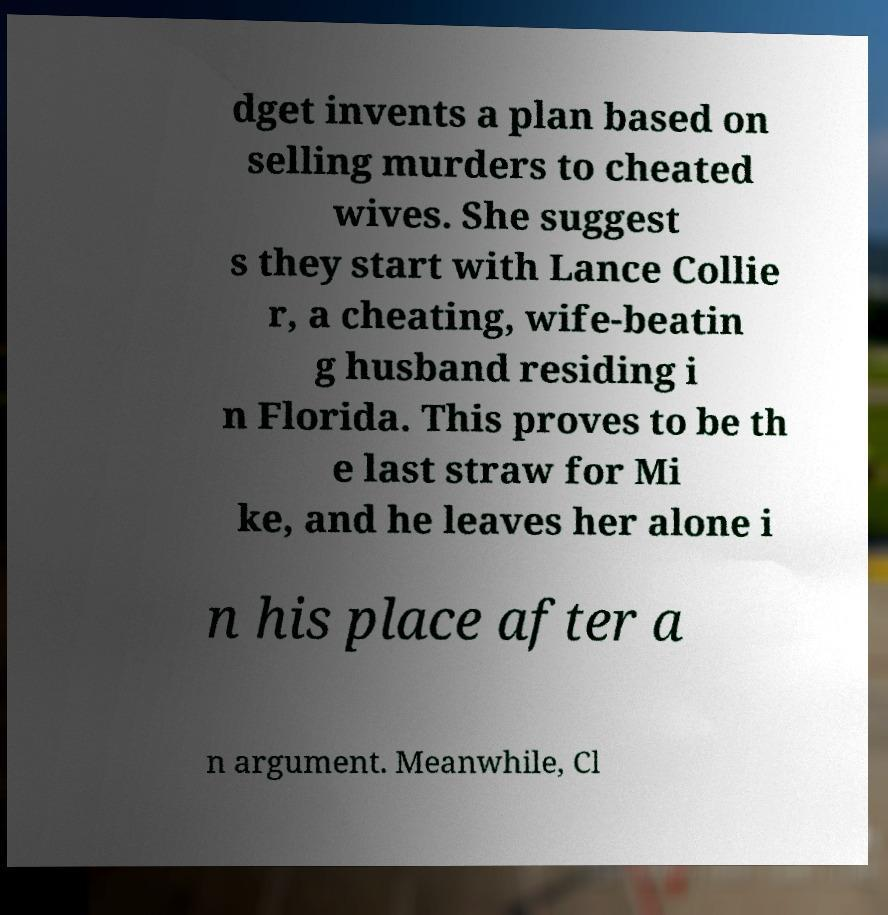Could you extract and type out the text from this image? dget invents a plan based on selling murders to cheated wives. She suggest s they start with Lance Collie r, a cheating, wife-beatin g husband residing i n Florida. This proves to be th e last straw for Mi ke, and he leaves her alone i n his place after a n argument. Meanwhile, Cl 